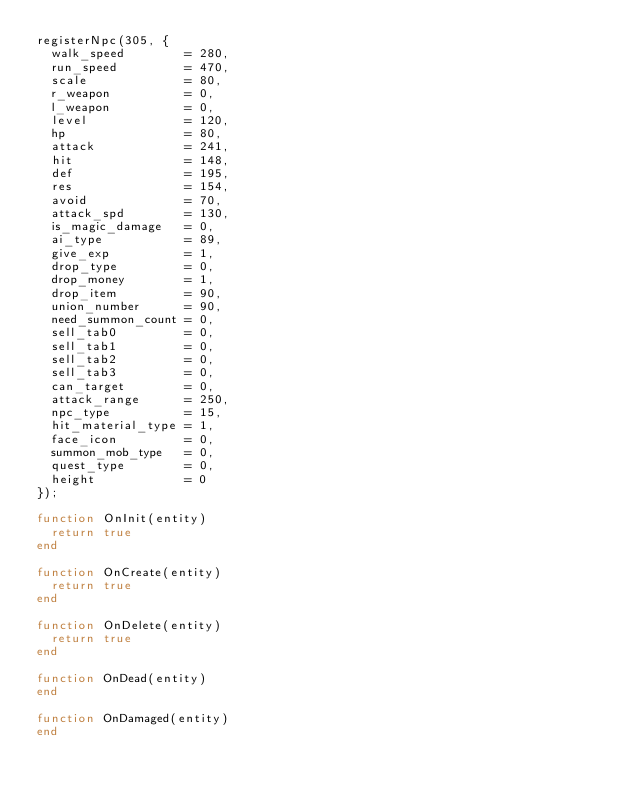<code> <loc_0><loc_0><loc_500><loc_500><_Lua_>registerNpc(305, {
  walk_speed        = 280,
  run_speed         = 470,
  scale             = 80,
  r_weapon          = 0,
  l_weapon          = 0,
  level             = 120,
  hp                = 80,
  attack            = 241,
  hit               = 148,
  def               = 195,
  res               = 154,
  avoid             = 70,
  attack_spd        = 130,
  is_magic_damage   = 0,
  ai_type           = 89,
  give_exp          = 1,
  drop_type         = 0,
  drop_money        = 1,
  drop_item         = 90,
  union_number      = 90,
  need_summon_count = 0,
  sell_tab0         = 0,
  sell_tab1         = 0,
  sell_tab2         = 0,
  sell_tab3         = 0,
  can_target        = 0,
  attack_range      = 250,
  npc_type          = 15,
  hit_material_type = 1,
  face_icon         = 0,
  summon_mob_type   = 0,
  quest_type        = 0,
  height            = 0
});

function OnInit(entity)
  return true
end

function OnCreate(entity)
  return true
end

function OnDelete(entity)
  return true
end

function OnDead(entity)
end

function OnDamaged(entity)
end</code> 